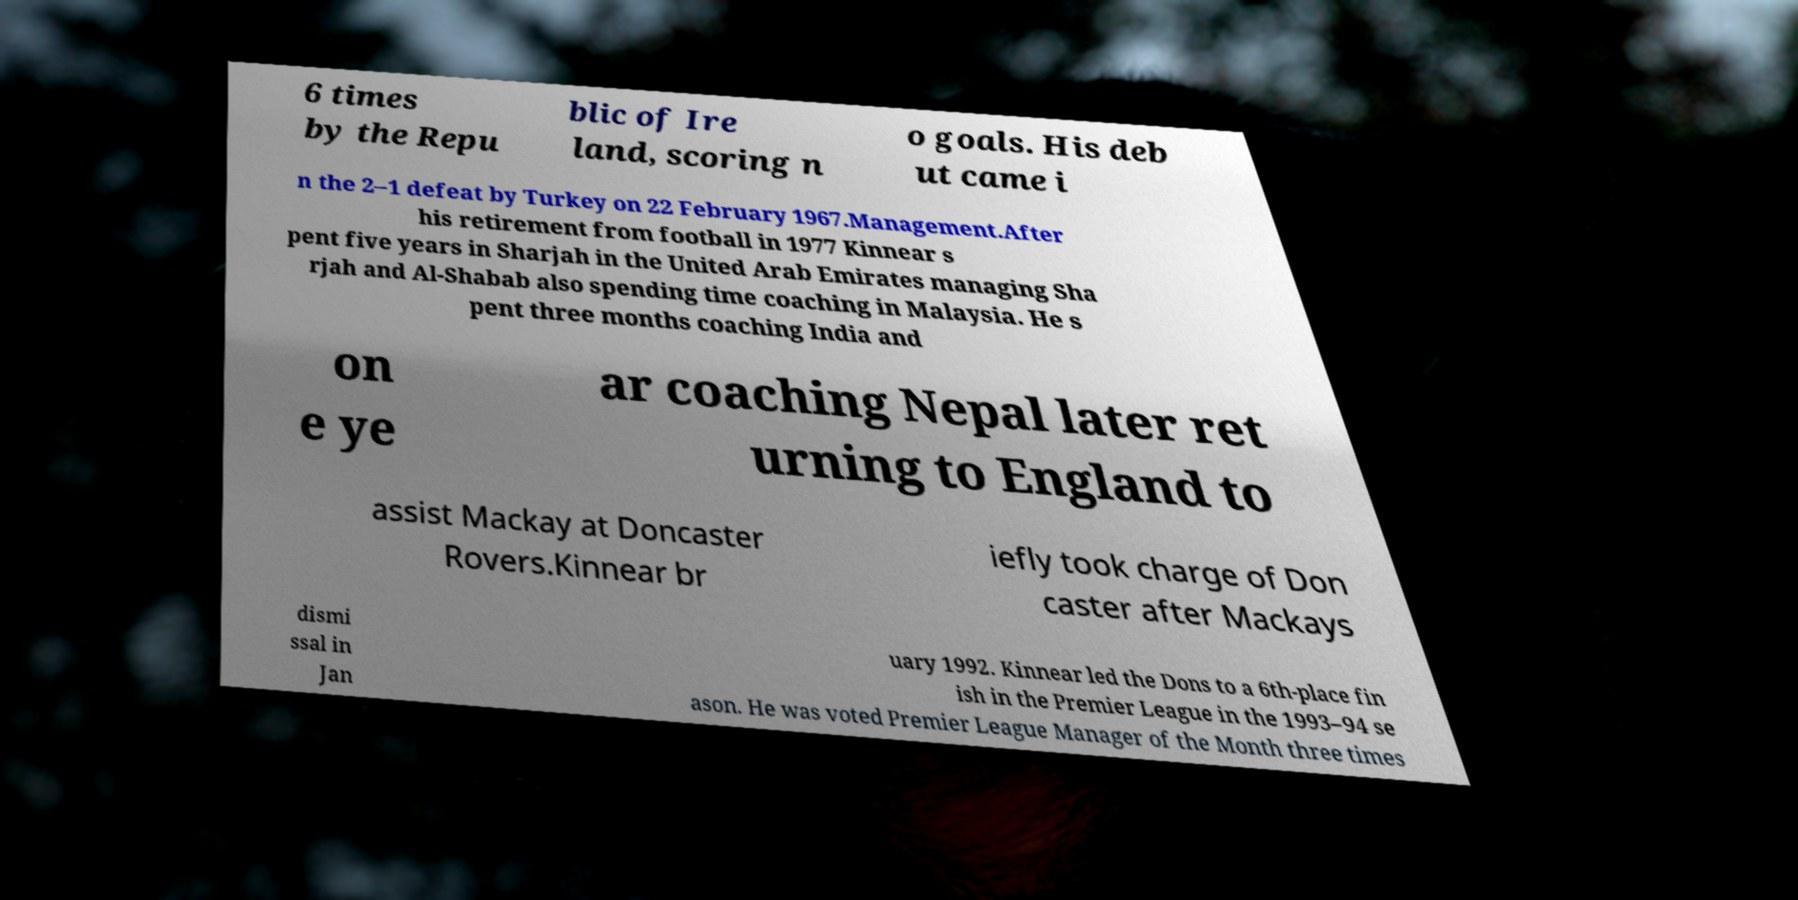There's text embedded in this image that I need extracted. Can you transcribe it verbatim? 6 times by the Repu blic of Ire land, scoring n o goals. His deb ut came i n the 2–1 defeat by Turkey on 22 February 1967.Management.After his retirement from football in 1977 Kinnear s pent five years in Sharjah in the United Arab Emirates managing Sha rjah and Al-Shabab also spending time coaching in Malaysia. He s pent three months coaching India and on e ye ar coaching Nepal later ret urning to England to assist Mackay at Doncaster Rovers.Kinnear br iefly took charge of Don caster after Mackays dismi ssal in Jan uary 1992. Kinnear led the Dons to a 6th-place fin ish in the Premier League in the 1993–94 se ason. He was voted Premier League Manager of the Month three times 